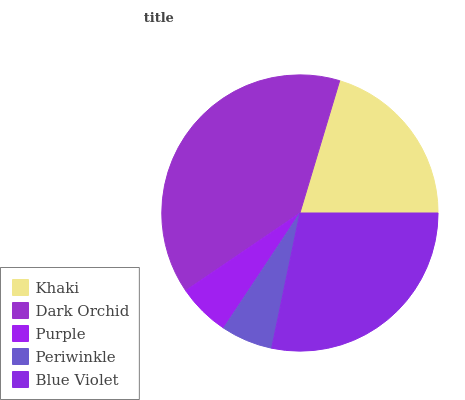Is Periwinkle the minimum?
Answer yes or no. Yes. Is Dark Orchid the maximum?
Answer yes or no. Yes. Is Purple the minimum?
Answer yes or no. No. Is Purple the maximum?
Answer yes or no. No. Is Dark Orchid greater than Purple?
Answer yes or no. Yes. Is Purple less than Dark Orchid?
Answer yes or no. Yes. Is Purple greater than Dark Orchid?
Answer yes or no. No. Is Dark Orchid less than Purple?
Answer yes or no. No. Is Khaki the high median?
Answer yes or no. Yes. Is Khaki the low median?
Answer yes or no. Yes. Is Blue Violet the high median?
Answer yes or no. No. Is Periwinkle the low median?
Answer yes or no. No. 